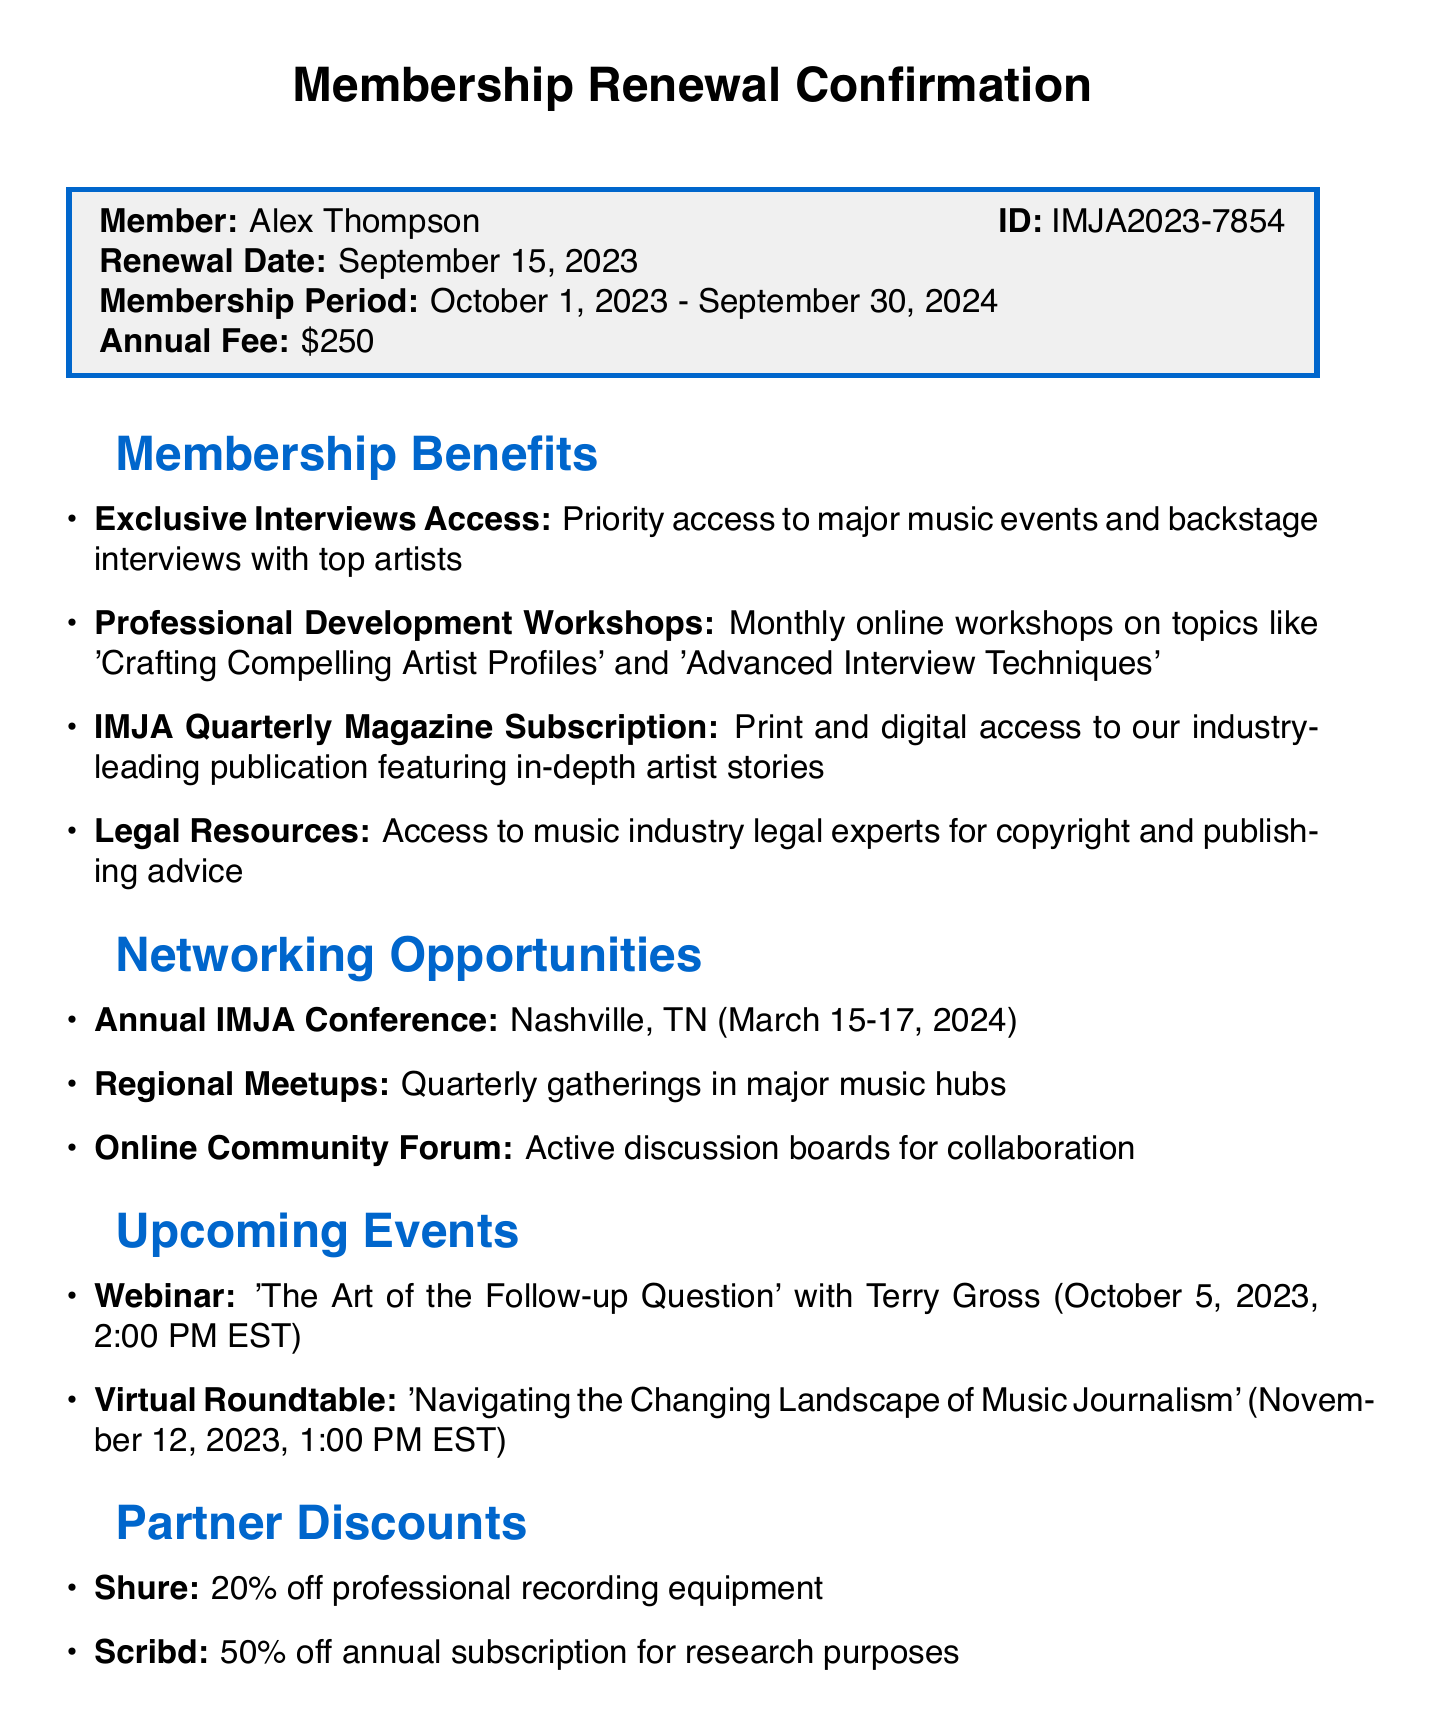What is the name of the association? The name of the association is provided at the start of the document.
Answer: International Music Journalists Association Who is the member? The member's name is listed in the member information section.
Answer: Alex Thompson What is the membership ID? The membership ID is specified in the member information section alongside the name.
Answer: IMJA2023-7854 What is the annual fee? The annual fee amount is clearly stated in the member information section.
Answer: $250 When does the membership period start? The start date of the membership period is listed in the membership information section.
Answer: October 1, 2023 Where is the Annual IMJA Conference taking place? The location of the Annual IMJA Conference is mentioned under networking opportunities.
Answer: Nashville, TN What discount does Shure offer? The discount from Shure is detailed in the partner discounts section.
Answer: 20% off professional recording equipment Who is the author of the testimonial? The author of the testimonial is identified at the end of the document.
Answer: Sarah Rodriguez What is the date of the upcoming webinar? The date of the webinar is specified in the upcoming events section.
Answer: October 5, 2023 How many professional development workshops are offered monthly? The number of workshops is inferred from the description in the benefits section.
Answer: Monthly 